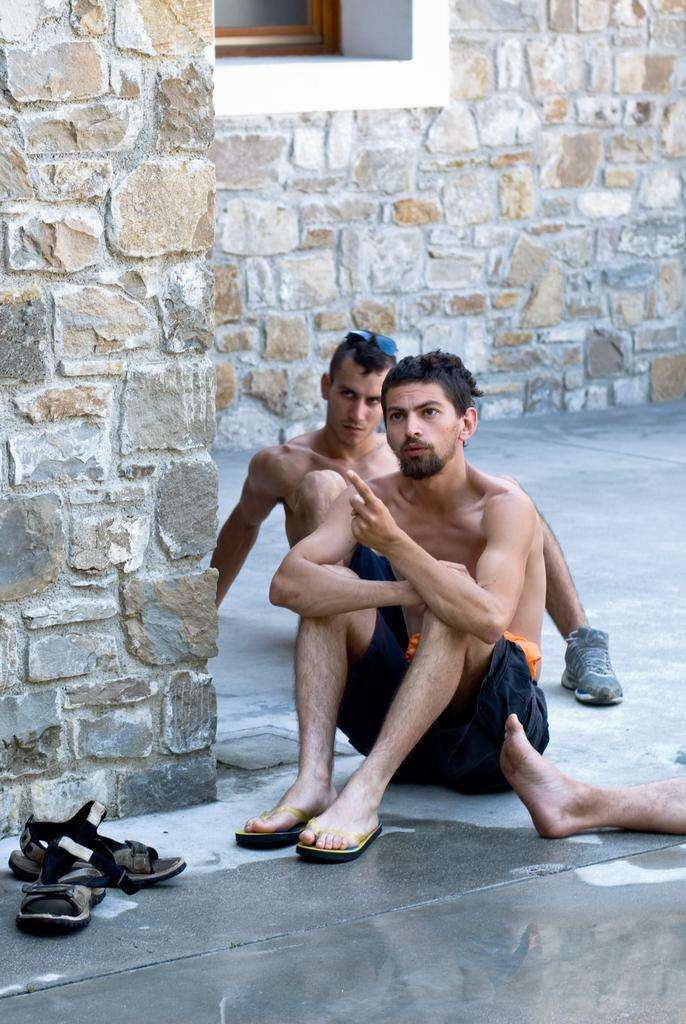What are the persons in the image doing? The persons in the image are sitting on the floor. What can be seen in the background of the image? There is a wall with a window in the background of the image. Where is the footwear located in the image? The footwear is present on the floor in the left bottom of the image. What part of a person's body is visible on the right side of the image? A person's leg is visible on the right side of the image. How many marbles are visible on the floor in the image? There are no marbles present in the image; only persons sitting on the floor, footwear, and a person's leg are visible. Are there any lizards crawling on the wall in the image? There is no mention of lizards in the image; only a wall with a window is described in the background. 